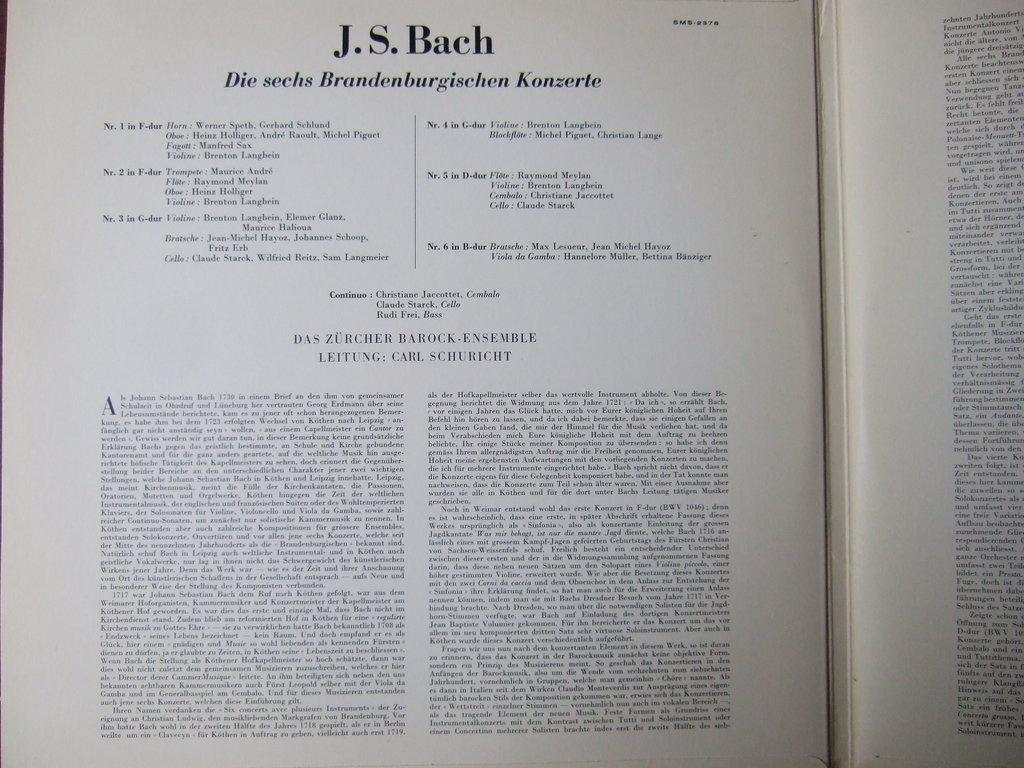Provide a one-sentence caption for the provided image. A open book with the page title reading J.S. Bach. 